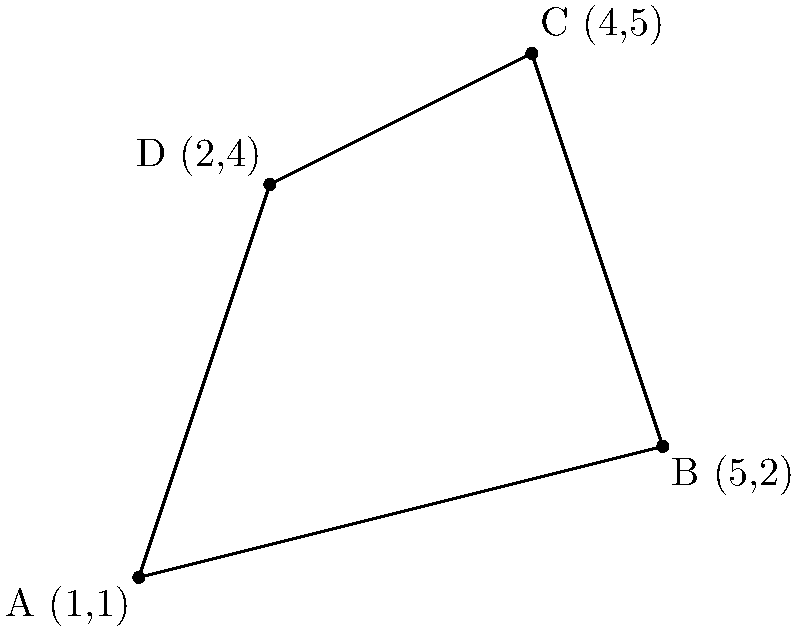As a motivational speaker focusing on strategic branding and positioning, you've plotted four key achievements on a coordinate system to visualize your area of influence. These achievements are represented by points A(1,1), B(5,2), C(4,5), and D(2,4). Calculate the area of influence enclosed by these points, which forms a quadrilateral ABCD. To find the area of the quadrilateral ABCD, we can use the following steps:

1) First, let's divide the quadrilateral into two triangles: ABC and ACD.

2) We can calculate the area of each triangle using the formula:
   Area = $\frac{1}{2}|x_1(y_2 - y_3) + x_2(y_3 - y_1) + x_3(y_1 - y_2)|$

3) For triangle ABC:
   $A_1 = \frac{1}{2}|1(2 - 5) + 5(5 - 1) + 4(1 - 2)|$
   $A_1 = \frac{1}{2}|1(-3) + 5(4) + 4(-1)|$
   $A_1 = \frac{1}{2}|-3 + 20 - 4|$
   $A_1 = \frac{1}{2}(13) = 6.5$

4) For triangle ACD:
   $A_2 = \frac{1}{2}|1(4 - 5) + 2(5 - 1) + 4(1 - 4)|$
   $A_2 = \frac{1}{2}|1(-1) + 2(4) + 4(-3)|$
   $A_2 = \frac{1}{2}|-1 + 8 - 12|$
   $A_2 = \frac{1}{2}(5) = 2.5$

5) The total area is the sum of these two triangles:
   Total Area = $A_1 + A_2 = 6.5 + 2.5 = 9$

Therefore, the area of influence enclosed by the four key achievements is 9 square units.
Answer: 9 square units 